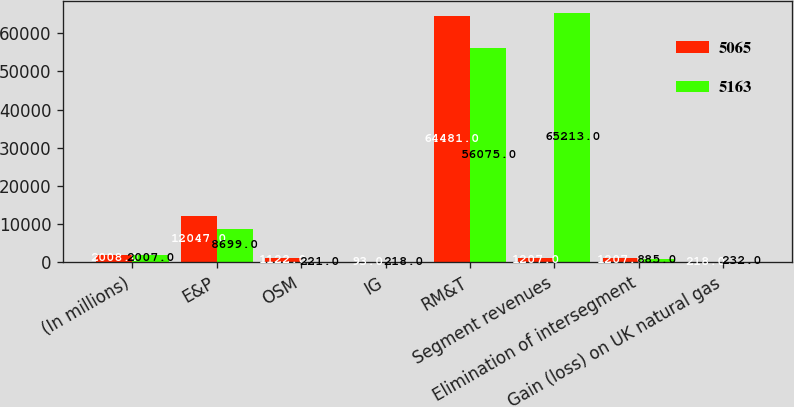Convert chart to OTSL. <chart><loc_0><loc_0><loc_500><loc_500><stacked_bar_chart><ecel><fcel>(In millions)<fcel>E&P<fcel>OSM<fcel>IG<fcel>RM&T<fcel>Segment revenues<fcel>Elimination of intersegment<fcel>Gain (loss) on UK natural gas<nl><fcel>5065<fcel>2008<fcel>12047<fcel>1122<fcel>93<fcel>64481<fcel>1207<fcel>1207<fcel>218<nl><fcel>5163<fcel>2007<fcel>8699<fcel>221<fcel>218<fcel>56075<fcel>65213<fcel>885<fcel>232<nl></chart> 